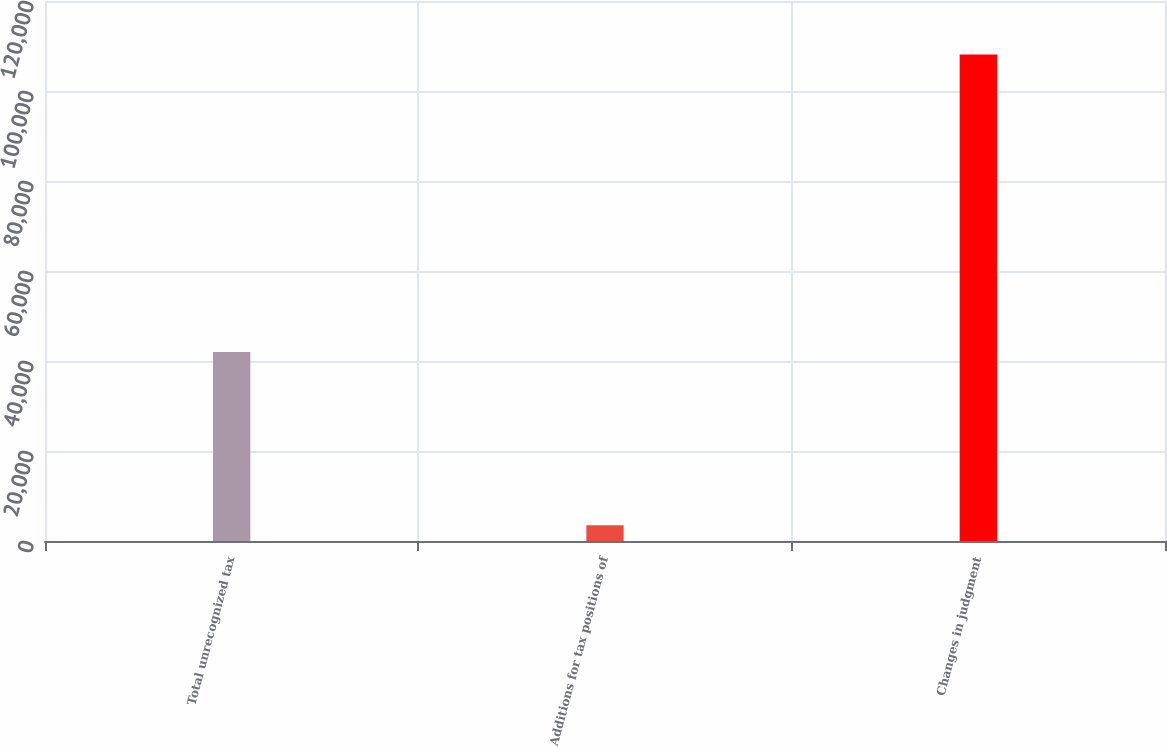Convert chart. <chart><loc_0><loc_0><loc_500><loc_500><bar_chart><fcel>Total unrecognized tax<fcel>Additions for tax positions of<fcel>Changes in judgment<nl><fcel>41997<fcel>3516<fcel>108099<nl></chart> 